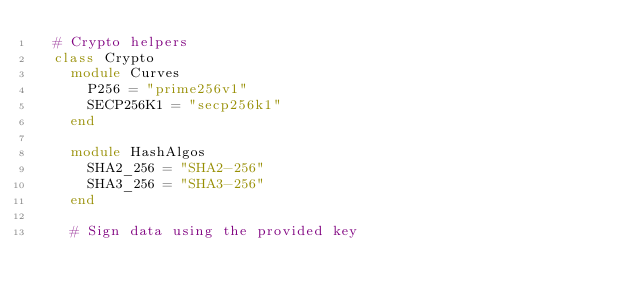Convert code to text. <code><loc_0><loc_0><loc_500><loc_500><_Ruby_>  # Crypto helpers
  class Crypto
    module Curves
      P256 = "prime256v1"
      SECP256K1 = "secp256k1"
    end

    module HashAlgos
      SHA2_256 = "SHA2-256"
      SHA3_256 = "SHA3-256"
    end

    # Sign data using the provided key</code> 